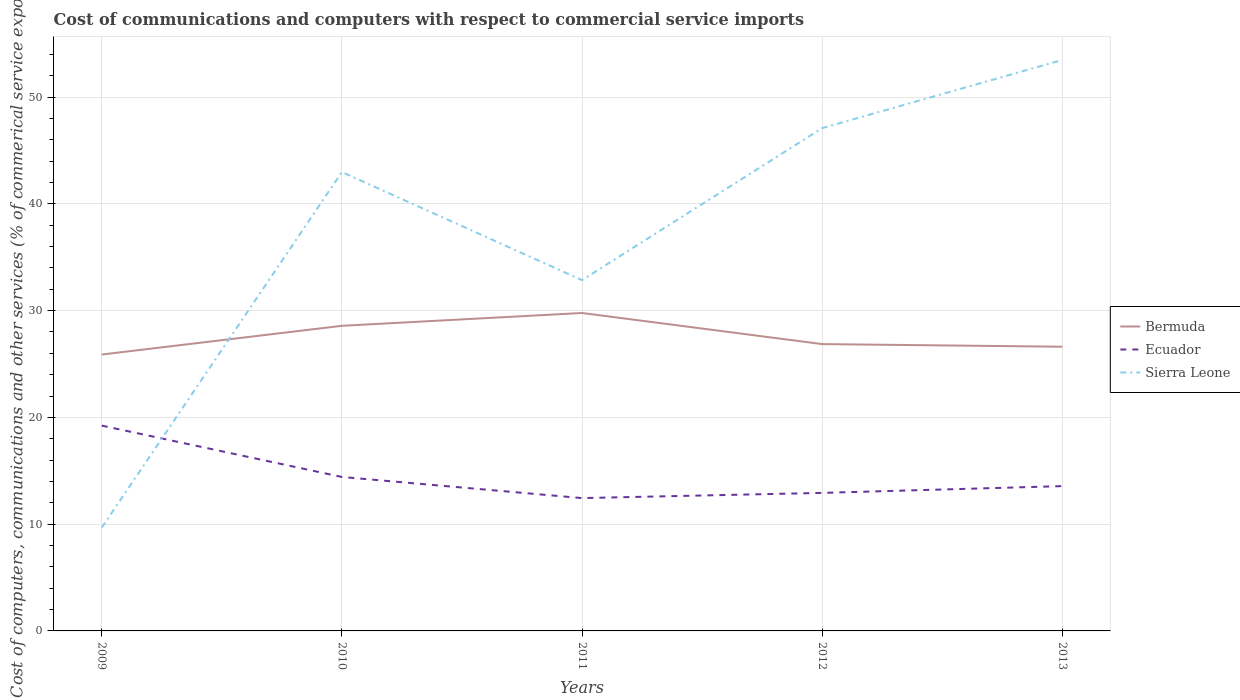Is the number of lines equal to the number of legend labels?
Your answer should be very brief. Yes. Across all years, what is the maximum cost of communications and computers in Bermuda?
Offer a very short reply. 25.89. What is the total cost of communications and computers in Bermuda in the graph?
Keep it short and to the point. -0.73. What is the difference between the highest and the second highest cost of communications and computers in Bermuda?
Ensure brevity in your answer.  3.89. What is the difference between the highest and the lowest cost of communications and computers in Sierra Leone?
Your response must be concise. 3. Is the cost of communications and computers in Bermuda strictly greater than the cost of communications and computers in Ecuador over the years?
Give a very brief answer. No. How many lines are there?
Your answer should be compact. 3. How many years are there in the graph?
Your answer should be compact. 5. Does the graph contain any zero values?
Provide a short and direct response. No. What is the title of the graph?
Ensure brevity in your answer.  Cost of communications and computers with respect to commercial service imports. What is the label or title of the X-axis?
Provide a short and direct response. Years. What is the label or title of the Y-axis?
Your response must be concise. Cost of computers, communications and other services (% of commerical service exports). What is the Cost of computers, communications and other services (% of commerical service exports) of Bermuda in 2009?
Provide a succinct answer. 25.89. What is the Cost of computers, communications and other services (% of commerical service exports) in Ecuador in 2009?
Your answer should be very brief. 19.23. What is the Cost of computers, communications and other services (% of commerical service exports) of Sierra Leone in 2009?
Your answer should be very brief. 9.67. What is the Cost of computers, communications and other services (% of commerical service exports) of Bermuda in 2010?
Give a very brief answer. 28.58. What is the Cost of computers, communications and other services (% of commerical service exports) in Ecuador in 2010?
Offer a terse response. 14.42. What is the Cost of computers, communications and other services (% of commerical service exports) of Sierra Leone in 2010?
Your response must be concise. 42.98. What is the Cost of computers, communications and other services (% of commerical service exports) of Bermuda in 2011?
Offer a very short reply. 29.78. What is the Cost of computers, communications and other services (% of commerical service exports) in Ecuador in 2011?
Make the answer very short. 12.44. What is the Cost of computers, communications and other services (% of commerical service exports) of Sierra Leone in 2011?
Provide a succinct answer. 32.86. What is the Cost of computers, communications and other services (% of commerical service exports) in Bermuda in 2012?
Your response must be concise. 26.86. What is the Cost of computers, communications and other services (% of commerical service exports) in Ecuador in 2012?
Ensure brevity in your answer.  12.93. What is the Cost of computers, communications and other services (% of commerical service exports) in Sierra Leone in 2012?
Ensure brevity in your answer.  47.09. What is the Cost of computers, communications and other services (% of commerical service exports) of Bermuda in 2013?
Ensure brevity in your answer.  26.62. What is the Cost of computers, communications and other services (% of commerical service exports) of Ecuador in 2013?
Provide a short and direct response. 13.56. What is the Cost of computers, communications and other services (% of commerical service exports) in Sierra Leone in 2013?
Ensure brevity in your answer.  53.47. Across all years, what is the maximum Cost of computers, communications and other services (% of commerical service exports) in Bermuda?
Make the answer very short. 29.78. Across all years, what is the maximum Cost of computers, communications and other services (% of commerical service exports) of Ecuador?
Provide a succinct answer. 19.23. Across all years, what is the maximum Cost of computers, communications and other services (% of commerical service exports) in Sierra Leone?
Provide a succinct answer. 53.47. Across all years, what is the minimum Cost of computers, communications and other services (% of commerical service exports) in Bermuda?
Provide a short and direct response. 25.89. Across all years, what is the minimum Cost of computers, communications and other services (% of commerical service exports) of Ecuador?
Keep it short and to the point. 12.44. Across all years, what is the minimum Cost of computers, communications and other services (% of commerical service exports) of Sierra Leone?
Give a very brief answer. 9.67. What is the total Cost of computers, communications and other services (% of commerical service exports) of Bermuda in the graph?
Your answer should be very brief. 137.72. What is the total Cost of computers, communications and other services (% of commerical service exports) of Ecuador in the graph?
Your answer should be compact. 72.58. What is the total Cost of computers, communications and other services (% of commerical service exports) in Sierra Leone in the graph?
Provide a succinct answer. 186.07. What is the difference between the Cost of computers, communications and other services (% of commerical service exports) of Bermuda in 2009 and that in 2010?
Offer a terse response. -2.69. What is the difference between the Cost of computers, communications and other services (% of commerical service exports) of Ecuador in 2009 and that in 2010?
Ensure brevity in your answer.  4.81. What is the difference between the Cost of computers, communications and other services (% of commerical service exports) in Sierra Leone in 2009 and that in 2010?
Provide a short and direct response. -33.3. What is the difference between the Cost of computers, communications and other services (% of commerical service exports) of Bermuda in 2009 and that in 2011?
Give a very brief answer. -3.89. What is the difference between the Cost of computers, communications and other services (% of commerical service exports) of Ecuador in 2009 and that in 2011?
Give a very brief answer. 6.79. What is the difference between the Cost of computers, communications and other services (% of commerical service exports) in Sierra Leone in 2009 and that in 2011?
Your response must be concise. -23.18. What is the difference between the Cost of computers, communications and other services (% of commerical service exports) in Bermuda in 2009 and that in 2012?
Provide a succinct answer. -0.98. What is the difference between the Cost of computers, communications and other services (% of commerical service exports) in Ecuador in 2009 and that in 2012?
Make the answer very short. 6.3. What is the difference between the Cost of computers, communications and other services (% of commerical service exports) in Sierra Leone in 2009 and that in 2012?
Provide a short and direct response. -37.42. What is the difference between the Cost of computers, communications and other services (% of commerical service exports) in Bermuda in 2009 and that in 2013?
Keep it short and to the point. -0.73. What is the difference between the Cost of computers, communications and other services (% of commerical service exports) of Ecuador in 2009 and that in 2013?
Ensure brevity in your answer.  5.67. What is the difference between the Cost of computers, communications and other services (% of commerical service exports) in Sierra Leone in 2009 and that in 2013?
Make the answer very short. -43.8. What is the difference between the Cost of computers, communications and other services (% of commerical service exports) of Bermuda in 2010 and that in 2011?
Keep it short and to the point. -1.2. What is the difference between the Cost of computers, communications and other services (% of commerical service exports) of Ecuador in 2010 and that in 2011?
Your answer should be compact. 1.98. What is the difference between the Cost of computers, communications and other services (% of commerical service exports) in Sierra Leone in 2010 and that in 2011?
Provide a succinct answer. 10.12. What is the difference between the Cost of computers, communications and other services (% of commerical service exports) in Bermuda in 2010 and that in 2012?
Provide a short and direct response. 1.71. What is the difference between the Cost of computers, communications and other services (% of commerical service exports) of Ecuador in 2010 and that in 2012?
Your answer should be compact. 1.49. What is the difference between the Cost of computers, communications and other services (% of commerical service exports) of Sierra Leone in 2010 and that in 2012?
Ensure brevity in your answer.  -4.11. What is the difference between the Cost of computers, communications and other services (% of commerical service exports) of Bermuda in 2010 and that in 2013?
Offer a very short reply. 1.96. What is the difference between the Cost of computers, communications and other services (% of commerical service exports) in Ecuador in 2010 and that in 2013?
Your answer should be very brief. 0.86. What is the difference between the Cost of computers, communications and other services (% of commerical service exports) of Sierra Leone in 2010 and that in 2013?
Offer a terse response. -10.5. What is the difference between the Cost of computers, communications and other services (% of commerical service exports) in Bermuda in 2011 and that in 2012?
Your answer should be compact. 2.91. What is the difference between the Cost of computers, communications and other services (% of commerical service exports) in Ecuador in 2011 and that in 2012?
Your answer should be compact. -0.49. What is the difference between the Cost of computers, communications and other services (% of commerical service exports) in Sierra Leone in 2011 and that in 2012?
Provide a succinct answer. -14.23. What is the difference between the Cost of computers, communications and other services (% of commerical service exports) of Bermuda in 2011 and that in 2013?
Offer a terse response. 3.16. What is the difference between the Cost of computers, communications and other services (% of commerical service exports) of Ecuador in 2011 and that in 2013?
Your response must be concise. -1.12. What is the difference between the Cost of computers, communications and other services (% of commerical service exports) in Sierra Leone in 2011 and that in 2013?
Give a very brief answer. -20.62. What is the difference between the Cost of computers, communications and other services (% of commerical service exports) in Bermuda in 2012 and that in 2013?
Ensure brevity in your answer.  0.25. What is the difference between the Cost of computers, communications and other services (% of commerical service exports) of Ecuador in 2012 and that in 2013?
Offer a terse response. -0.63. What is the difference between the Cost of computers, communications and other services (% of commerical service exports) of Sierra Leone in 2012 and that in 2013?
Offer a very short reply. -6.38. What is the difference between the Cost of computers, communications and other services (% of commerical service exports) in Bermuda in 2009 and the Cost of computers, communications and other services (% of commerical service exports) in Ecuador in 2010?
Provide a short and direct response. 11.47. What is the difference between the Cost of computers, communications and other services (% of commerical service exports) in Bermuda in 2009 and the Cost of computers, communications and other services (% of commerical service exports) in Sierra Leone in 2010?
Offer a very short reply. -17.09. What is the difference between the Cost of computers, communications and other services (% of commerical service exports) of Ecuador in 2009 and the Cost of computers, communications and other services (% of commerical service exports) of Sierra Leone in 2010?
Ensure brevity in your answer.  -23.75. What is the difference between the Cost of computers, communications and other services (% of commerical service exports) of Bermuda in 2009 and the Cost of computers, communications and other services (% of commerical service exports) of Ecuador in 2011?
Provide a short and direct response. 13.45. What is the difference between the Cost of computers, communications and other services (% of commerical service exports) in Bermuda in 2009 and the Cost of computers, communications and other services (% of commerical service exports) in Sierra Leone in 2011?
Make the answer very short. -6.97. What is the difference between the Cost of computers, communications and other services (% of commerical service exports) of Ecuador in 2009 and the Cost of computers, communications and other services (% of commerical service exports) of Sierra Leone in 2011?
Offer a very short reply. -13.63. What is the difference between the Cost of computers, communications and other services (% of commerical service exports) in Bermuda in 2009 and the Cost of computers, communications and other services (% of commerical service exports) in Ecuador in 2012?
Keep it short and to the point. 12.96. What is the difference between the Cost of computers, communications and other services (% of commerical service exports) in Bermuda in 2009 and the Cost of computers, communications and other services (% of commerical service exports) in Sierra Leone in 2012?
Keep it short and to the point. -21.2. What is the difference between the Cost of computers, communications and other services (% of commerical service exports) of Ecuador in 2009 and the Cost of computers, communications and other services (% of commerical service exports) of Sierra Leone in 2012?
Provide a short and direct response. -27.86. What is the difference between the Cost of computers, communications and other services (% of commerical service exports) of Bermuda in 2009 and the Cost of computers, communications and other services (% of commerical service exports) of Ecuador in 2013?
Offer a very short reply. 12.33. What is the difference between the Cost of computers, communications and other services (% of commerical service exports) of Bermuda in 2009 and the Cost of computers, communications and other services (% of commerical service exports) of Sierra Leone in 2013?
Provide a short and direct response. -27.59. What is the difference between the Cost of computers, communications and other services (% of commerical service exports) of Ecuador in 2009 and the Cost of computers, communications and other services (% of commerical service exports) of Sierra Leone in 2013?
Your response must be concise. -34.24. What is the difference between the Cost of computers, communications and other services (% of commerical service exports) in Bermuda in 2010 and the Cost of computers, communications and other services (% of commerical service exports) in Ecuador in 2011?
Your answer should be very brief. 16.14. What is the difference between the Cost of computers, communications and other services (% of commerical service exports) of Bermuda in 2010 and the Cost of computers, communications and other services (% of commerical service exports) of Sierra Leone in 2011?
Provide a succinct answer. -4.28. What is the difference between the Cost of computers, communications and other services (% of commerical service exports) in Ecuador in 2010 and the Cost of computers, communications and other services (% of commerical service exports) in Sierra Leone in 2011?
Ensure brevity in your answer.  -18.44. What is the difference between the Cost of computers, communications and other services (% of commerical service exports) in Bermuda in 2010 and the Cost of computers, communications and other services (% of commerical service exports) in Ecuador in 2012?
Provide a short and direct response. 15.65. What is the difference between the Cost of computers, communications and other services (% of commerical service exports) in Bermuda in 2010 and the Cost of computers, communications and other services (% of commerical service exports) in Sierra Leone in 2012?
Your answer should be very brief. -18.51. What is the difference between the Cost of computers, communications and other services (% of commerical service exports) of Ecuador in 2010 and the Cost of computers, communications and other services (% of commerical service exports) of Sierra Leone in 2012?
Provide a short and direct response. -32.67. What is the difference between the Cost of computers, communications and other services (% of commerical service exports) in Bermuda in 2010 and the Cost of computers, communications and other services (% of commerical service exports) in Ecuador in 2013?
Ensure brevity in your answer.  15.01. What is the difference between the Cost of computers, communications and other services (% of commerical service exports) in Bermuda in 2010 and the Cost of computers, communications and other services (% of commerical service exports) in Sierra Leone in 2013?
Your answer should be compact. -24.9. What is the difference between the Cost of computers, communications and other services (% of commerical service exports) in Ecuador in 2010 and the Cost of computers, communications and other services (% of commerical service exports) in Sierra Leone in 2013?
Make the answer very short. -39.05. What is the difference between the Cost of computers, communications and other services (% of commerical service exports) in Bermuda in 2011 and the Cost of computers, communications and other services (% of commerical service exports) in Ecuador in 2012?
Give a very brief answer. 16.85. What is the difference between the Cost of computers, communications and other services (% of commerical service exports) in Bermuda in 2011 and the Cost of computers, communications and other services (% of commerical service exports) in Sierra Leone in 2012?
Provide a short and direct response. -17.31. What is the difference between the Cost of computers, communications and other services (% of commerical service exports) of Ecuador in 2011 and the Cost of computers, communications and other services (% of commerical service exports) of Sierra Leone in 2012?
Offer a terse response. -34.65. What is the difference between the Cost of computers, communications and other services (% of commerical service exports) in Bermuda in 2011 and the Cost of computers, communications and other services (% of commerical service exports) in Ecuador in 2013?
Give a very brief answer. 16.21. What is the difference between the Cost of computers, communications and other services (% of commerical service exports) of Bermuda in 2011 and the Cost of computers, communications and other services (% of commerical service exports) of Sierra Leone in 2013?
Make the answer very short. -23.7. What is the difference between the Cost of computers, communications and other services (% of commerical service exports) in Ecuador in 2011 and the Cost of computers, communications and other services (% of commerical service exports) in Sierra Leone in 2013?
Keep it short and to the point. -41.03. What is the difference between the Cost of computers, communications and other services (% of commerical service exports) in Bermuda in 2012 and the Cost of computers, communications and other services (% of commerical service exports) in Ecuador in 2013?
Ensure brevity in your answer.  13.3. What is the difference between the Cost of computers, communications and other services (% of commerical service exports) of Bermuda in 2012 and the Cost of computers, communications and other services (% of commerical service exports) of Sierra Leone in 2013?
Provide a short and direct response. -26.61. What is the difference between the Cost of computers, communications and other services (% of commerical service exports) of Ecuador in 2012 and the Cost of computers, communications and other services (% of commerical service exports) of Sierra Leone in 2013?
Your response must be concise. -40.55. What is the average Cost of computers, communications and other services (% of commerical service exports) of Bermuda per year?
Keep it short and to the point. 27.54. What is the average Cost of computers, communications and other services (% of commerical service exports) in Ecuador per year?
Offer a very short reply. 14.52. What is the average Cost of computers, communications and other services (% of commerical service exports) of Sierra Leone per year?
Give a very brief answer. 37.21. In the year 2009, what is the difference between the Cost of computers, communications and other services (% of commerical service exports) in Bermuda and Cost of computers, communications and other services (% of commerical service exports) in Ecuador?
Your answer should be very brief. 6.66. In the year 2009, what is the difference between the Cost of computers, communications and other services (% of commerical service exports) of Bermuda and Cost of computers, communications and other services (% of commerical service exports) of Sierra Leone?
Offer a terse response. 16.21. In the year 2009, what is the difference between the Cost of computers, communications and other services (% of commerical service exports) of Ecuador and Cost of computers, communications and other services (% of commerical service exports) of Sierra Leone?
Your answer should be compact. 9.55. In the year 2010, what is the difference between the Cost of computers, communications and other services (% of commerical service exports) of Bermuda and Cost of computers, communications and other services (% of commerical service exports) of Ecuador?
Provide a succinct answer. 14.16. In the year 2010, what is the difference between the Cost of computers, communications and other services (% of commerical service exports) of Bermuda and Cost of computers, communications and other services (% of commerical service exports) of Sierra Leone?
Ensure brevity in your answer.  -14.4. In the year 2010, what is the difference between the Cost of computers, communications and other services (% of commerical service exports) in Ecuador and Cost of computers, communications and other services (% of commerical service exports) in Sierra Leone?
Offer a terse response. -28.56. In the year 2011, what is the difference between the Cost of computers, communications and other services (% of commerical service exports) of Bermuda and Cost of computers, communications and other services (% of commerical service exports) of Ecuador?
Your answer should be compact. 17.34. In the year 2011, what is the difference between the Cost of computers, communications and other services (% of commerical service exports) in Bermuda and Cost of computers, communications and other services (% of commerical service exports) in Sierra Leone?
Provide a succinct answer. -3.08. In the year 2011, what is the difference between the Cost of computers, communications and other services (% of commerical service exports) in Ecuador and Cost of computers, communications and other services (% of commerical service exports) in Sierra Leone?
Make the answer very short. -20.42. In the year 2012, what is the difference between the Cost of computers, communications and other services (% of commerical service exports) in Bermuda and Cost of computers, communications and other services (% of commerical service exports) in Ecuador?
Your answer should be compact. 13.94. In the year 2012, what is the difference between the Cost of computers, communications and other services (% of commerical service exports) of Bermuda and Cost of computers, communications and other services (% of commerical service exports) of Sierra Leone?
Keep it short and to the point. -20.23. In the year 2012, what is the difference between the Cost of computers, communications and other services (% of commerical service exports) of Ecuador and Cost of computers, communications and other services (% of commerical service exports) of Sierra Leone?
Offer a very short reply. -34.16. In the year 2013, what is the difference between the Cost of computers, communications and other services (% of commerical service exports) in Bermuda and Cost of computers, communications and other services (% of commerical service exports) in Ecuador?
Your response must be concise. 13.06. In the year 2013, what is the difference between the Cost of computers, communications and other services (% of commerical service exports) in Bermuda and Cost of computers, communications and other services (% of commerical service exports) in Sierra Leone?
Provide a succinct answer. -26.86. In the year 2013, what is the difference between the Cost of computers, communications and other services (% of commerical service exports) in Ecuador and Cost of computers, communications and other services (% of commerical service exports) in Sierra Leone?
Make the answer very short. -39.91. What is the ratio of the Cost of computers, communications and other services (% of commerical service exports) in Bermuda in 2009 to that in 2010?
Make the answer very short. 0.91. What is the ratio of the Cost of computers, communications and other services (% of commerical service exports) of Ecuador in 2009 to that in 2010?
Your response must be concise. 1.33. What is the ratio of the Cost of computers, communications and other services (% of commerical service exports) in Sierra Leone in 2009 to that in 2010?
Your answer should be compact. 0.23. What is the ratio of the Cost of computers, communications and other services (% of commerical service exports) of Bermuda in 2009 to that in 2011?
Make the answer very short. 0.87. What is the ratio of the Cost of computers, communications and other services (% of commerical service exports) of Ecuador in 2009 to that in 2011?
Provide a short and direct response. 1.55. What is the ratio of the Cost of computers, communications and other services (% of commerical service exports) of Sierra Leone in 2009 to that in 2011?
Your answer should be compact. 0.29. What is the ratio of the Cost of computers, communications and other services (% of commerical service exports) of Bermuda in 2009 to that in 2012?
Offer a very short reply. 0.96. What is the ratio of the Cost of computers, communications and other services (% of commerical service exports) of Ecuador in 2009 to that in 2012?
Offer a terse response. 1.49. What is the ratio of the Cost of computers, communications and other services (% of commerical service exports) of Sierra Leone in 2009 to that in 2012?
Your response must be concise. 0.21. What is the ratio of the Cost of computers, communications and other services (% of commerical service exports) in Bermuda in 2009 to that in 2013?
Keep it short and to the point. 0.97. What is the ratio of the Cost of computers, communications and other services (% of commerical service exports) in Ecuador in 2009 to that in 2013?
Give a very brief answer. 1.42. What is the ratio of the Cost of computers, communications and other services (% of commerical service exports) of Sierra Leone in 2009 to that in 2013?
Your answer should be very brief. 0.18. What is the ratio of the Cost of computers, communications and other services (% of commerical service exports) of Bermuda in 2010 to that in 2011?
Your answer should be very brief. 0.96. What is the ratio of the Cost of computers, communications and other services (% of commerical service exports) in Ecuador in 2010 to that in 2011?
Your answer should be compact. 1.16. What is the ratio of the Cost of computers, communications and other services (% of commerical service exports) in Sierra Leone in 2010 to that in 2011?
Make the answer very short. 1.31. What is the ratio of the Cost of computers, communications and other services (% of commerical service exports) of Bermuda in 2010 to that in 2012?
Give a very brief answer. 1.06. What is the ratio of the Cost of computers, communications and other services (% of commerical service exports) in Ecuador in 2010 to that in 2012?
Make the answer very short. 1.12. What is the ratio of the Cost of computers, communications and other services (% of commerical service exports) in Sierra Leone in 2010 to that in 2012?
Provide a short and direct response. 0.91. What is the ratio of the Cost of computers, communications and other services (% of commerical service exports) of Bermuda in 2010 to that in 2013?
Ensure brevity in your answer.  1.07. What is the ratio of the Cost of computers, communications and other services (% of commerical service exports) of Ecuador in 2010 to that in 2013?
Offer a terse response. 1.06. What is the ratio of the Cost of computers, communications and other services (% of commerical service exports) of Sierra Leone in 2010 to that in 2013?
Make the answer very short. 0.8. What is the ratio of the Cost of computers, communications and other services (% of commerical service exports) in Bermuda in 2011 to that in 2012?
Offer a terse response. 1.11. What is the ratio of the Cost of computers, communications and other services (% of commerical service exports) in Ecuador in 2011 to that in 2012?
Offer a terse response. 0.96. What is the ratio of the Cost of computers, communications and other services (% of commerical service exports) in Sierra Leone in 2011 to that in 2012?
Make the answer very short. 0.7. What is the ratio of the Cost of computers, communications and other services (% of commerical service exports) in Bermuda in 2011 to that in 2013?
Keep it short and to the point. 1.12. What is the ratio of the Cost of computers, communications and other services (% of commerical service exports) in Ecuador in 2011 to that in 2013?
Ensure brevity in your answer.  0.92. What is the ratio of the Cost of computers, communications and other services (% of commerical service exports) of Sierra Leone in 2011 to that in 2013?
Your response must be concise. 0.61. What is the ratio of the Cost of computers, communications and other services (% of commerical service exports) of Bermuda in 2012 to that in 2013?
Keep it short and to the point. 1.01. What is the ratio of the Cost of computers, communications and other services (% of commerical service exports) of Ecuador in 2012 to that in 2013?
Offer a very short reply. 0.95. What is the ratio of the Cost of computers, communications and other services (% of commerical service exports) in Sierra Leone in 2012 to that in 2013?
Keep it short and to the point. 0.88. What is the difference between the highest and the second highest Cost of computers, communications and other services (% of commerical service exports) of Bermuda?
Your response must be concise. 1.2. What is the difference between the highest and the second highest Cost of computers, communications and other services (% of commerical service exports) in Ecuador?
Keep it short and to the point. 4.81. What is the difference between the highest and the second highest Cost of computers, communications and other services (% of commerical service exports) of Sierra Leone?
Provide a short and direct response. 6.38. What is the difference between the highest and the lowest Cost of computers, communications and other services (% of commerical service exports) of Bermuda?
Provide a short and direct response. 3.89. What is the difference between the highest and the lowest Cost of computers, communications and other services (% of commerical service exports) in Ecuador?
Your response must be concise. 6.79. What is the difference between the highest and the lowest Cost of computers, communications and other services (% of commerical service exports) in Sierra Leone?
Keep it short and to the point. 43.8. 